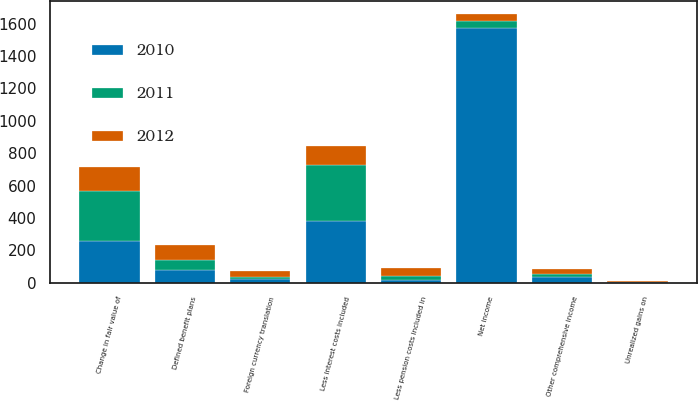Convert chart to OTSL. <chart><loc_0><loc_0><loc_500><loc_500><stacked_bar_chart><ecel><fcel>Net income<fcel>Foreign currency translation<fcel>Unrealized gains on<fcel>Defined benefit plans<fcel>Less pension costs included in<fcel>Change in fair value of<fcel>Less interest costs included<fcel>Other comprehensive income<nl><fcel>2012<fcel>41.5<fcel>37<fcel>6<fcel>89<fcel>46<fcel>151<fcel>122<fcel>29<nl><fcel>2011<fcel>41.5<fcel>9<fcel>2<fcel>67<fcel>25<fcel>311<fcel>341<fcel>19<nl><fcel>2010<fcel>1573<fcel>25<fcel>2<fcel>76<fcel>18<fcel>255<fcel>384<fcel>35<nl></chart> 